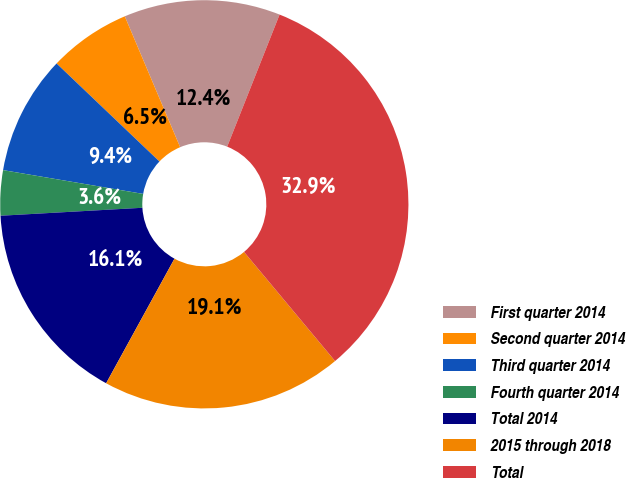<chart> <loc_0><loc_0><loc_500><loc_500><pie_chart><fcel>First quarter 2014<fcel>Second quarter 2014<fcel>Third quarter 2014<fcel>Fourth quarter 2014<fcel>Total 2014<fcel>2015 through 2018<fcel>Total<nl><fcel>12.38%<fcel>6.51%<fcel>9.44%<fcel>3.57%<fcel>16.12%<fcel>19.05%<fcel>32.92%<nl></chart> 